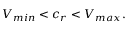Convert formula to latex. <formula><loc_0><loc_0><loc_500><loc_500>\begin{array} { r } { V _ { \min } < c _ { r } < V _ { \max } . } \end{array}</formula> 